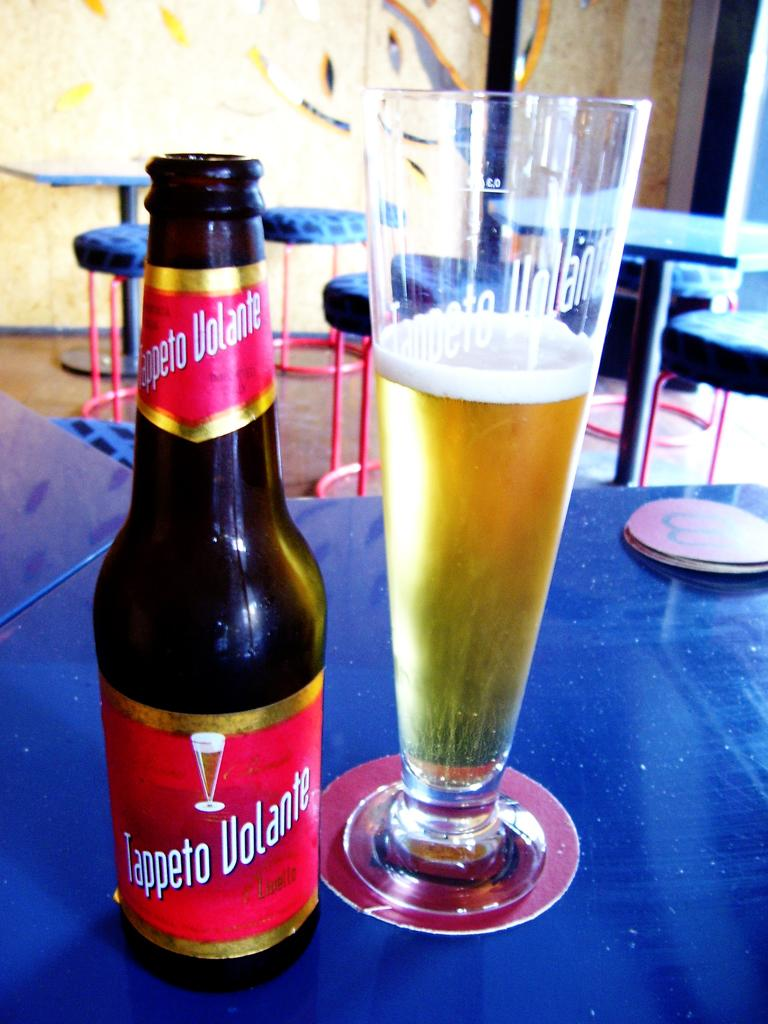Provide a one-sentence caption for the provided image. A tall glass of beer sits on a table next to a Tappeto Volante bottle. 